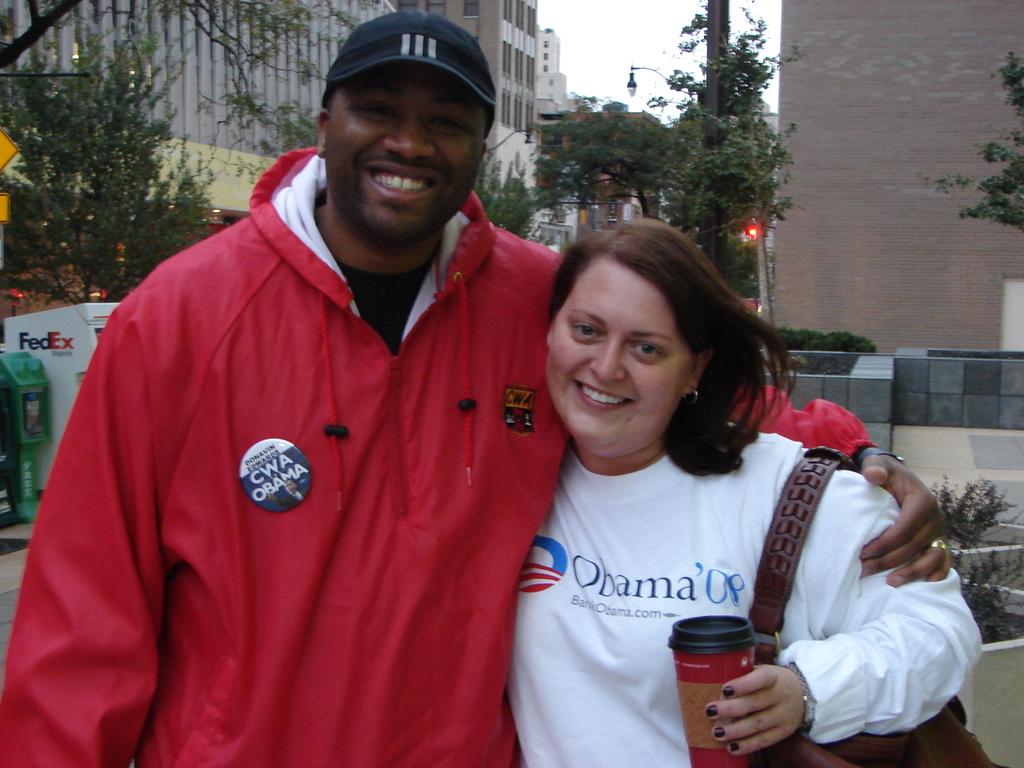Who is the woman supporting according to her sweatshirt?
Your response must be concise. Obama. 